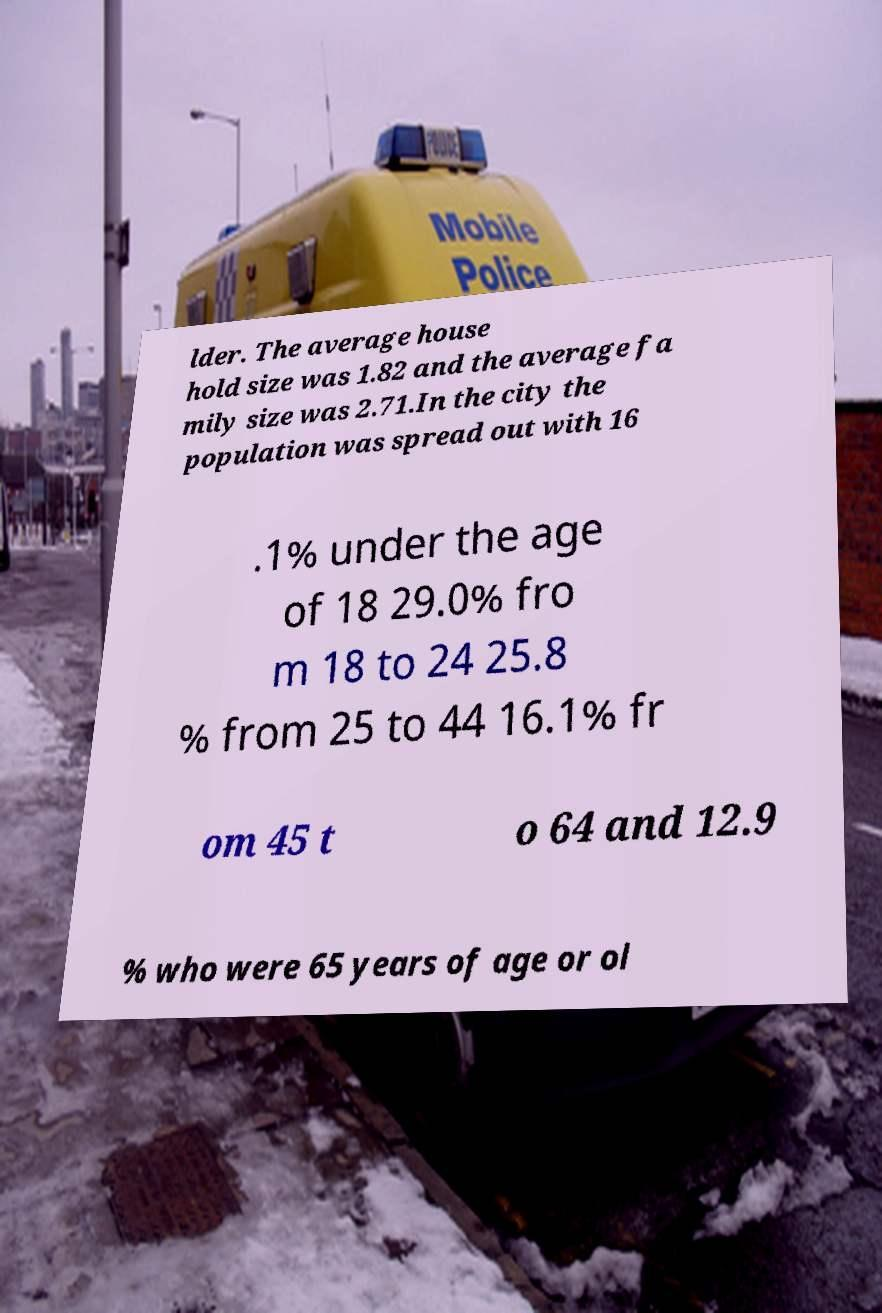For documentation purposes, I need the text within this image transcribed. Could you provide that? lder. The average house hold size was 1.82 and the average fa mily size was 2.71.In the city the population was spread out with 16 .1% under the age of 18 29.0% fro m 18 to 24 25.8 % from 25 to 44 16.1% fr om 45 t o 64 and 12.9 % who were 65 years of age or ol 